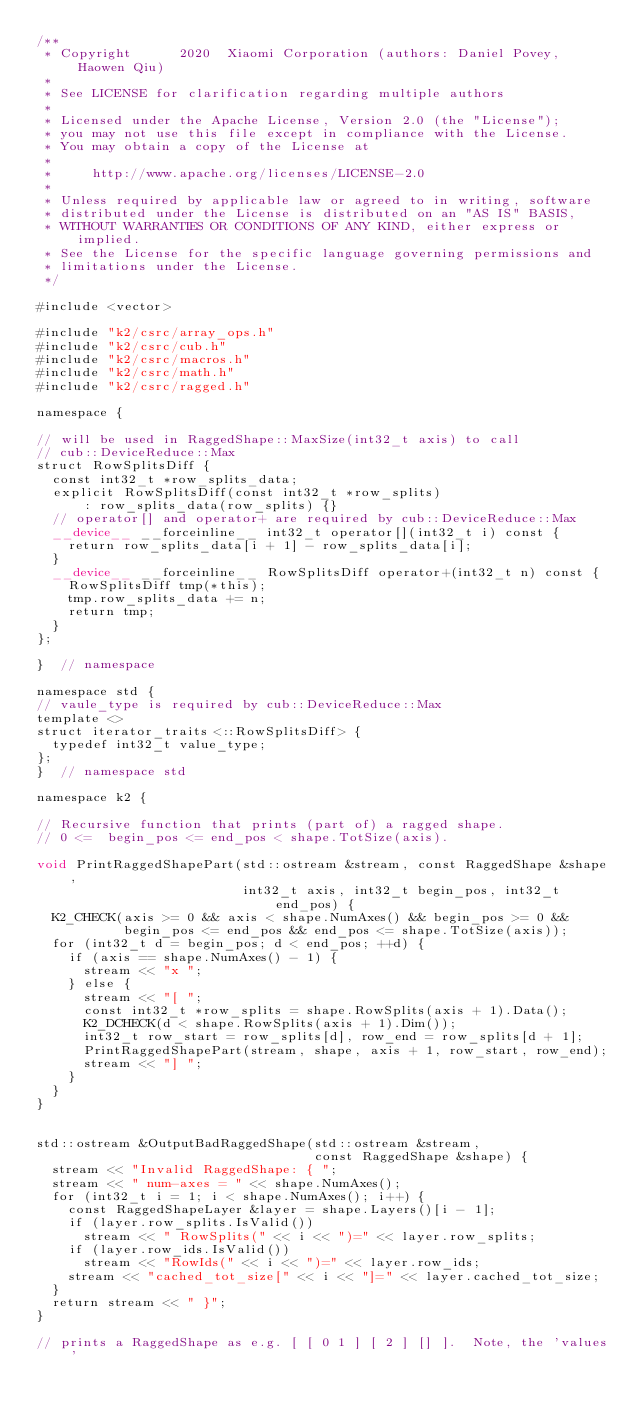Convert code to text. <code><loc_0><loc_0><loc_500><loc_500><_Cuda_>/**
 * Copyright      2020  Xiaomi Corporation (authors: Daniel Povey, Haowen Qiu)
 *
 * See LICENSE for clarification regarding multiple authors
 *
 * Licensed under the Apache License, Version 2.0 (the "License");
 * you may not use this file except in compliance with the License.
 * You may obtain a copy of the License at
 *
 *     http://www.apache.org/licenses/LICENSE-2.0
 *
 * Unless required by applicable law or agreed to in writing, software
 * distributed under the License is distributed on an "AS IS" BASIS,
 * WITHOUT WARRANTIES OR CONDITIONS OF ANY KIND, either express or implied.
 * See the License for the specific language governing permissions and
 * limitations under the License.
 */

#include <vector>

#include "k2/csrc/array_ops.h"
#include "k2/csrc/cub.h"
#include "k2/csrc/macros.h"
#include "k2/csrc/math.h"
#include "k2/csrc/ragged.h"

namespace {

// will be used in RaggedShape::MaxSize(int32_t axis) to call
// cub::DeviceReduce::Max
struct RowSplitsDiff {
  const int32_t *row_splits_data;
  explicit RowSplitsDiff(const int32_t *row_splits)
      : row_splits_data(row_splits) {}
  // operator[] and operator+ are required by cub::DeviceReduce::Max
  __device__ __forceinline__ int32_t operator[](int32_t i) const {
    return row_splits_data[i + 1] - row_splits_data[i];
  }
  __device__ __forceinline__ RowSplitsDiff operator+(int32_t n) const {
    RowSplitsDiff tmp(*this);
    tmp.row_splits_data += n;
    return tmp;
  }
};

}  // namespace

namespace std {
// vaule_type is required by cub::DeviceReduce::Max
template <>
struct iterator_traits<::RowSplitsDiff> {
  typedef int32_t value_type;
};
}  // namespace std

namespace k2 {

// Recursive function that prints (part of) a ragged shape.
// 0 <=  begin_pos <= end_pos < shape.TotSize(axis).

void PrintRaggedShapePart(std::ostream &stream, const RaggedShape &shape,
                          int32_t axis, int32_t begin_pos, int32_t end_pos) {
  K2_CHECK(axis >= 0 && axis < shape.NumAxes() && begin_pos >= 0 &&
           begin_pos <= end_pos && end_pos <= shape.TotSize(axis));
  for (int32_t d = begin_pos; d < end_pos; ++d) {
    if (axis == shape.NumAxes() - 1) {
      stream << "x ";
    } else {
      stream << "[ ";
      const int32_t *row_splits = shape.RowSplits(axis + 1).Data();
      K2_DCHECK(d < shape.RowSplits(axis + 1).Dim());
      int32_t row_start = row_splits[d], row_end = row_splits[d + 1];
      PrintRaggedShapePart(stream, shape, axis + 1, row_start, row_end);
      stream << "] ";
    }
  }
}


std::ostream &OutputBadRaggedShape(std::ostream &stream,
                                   const RaggedShape &shape) {
  stream << "Invalid RaggedShape: { ";
  stream << " num-axes = " << shape.NumAxes();
  for (int32_t i = 1; i < shape.NumAxes(); i++) {
    const RaggedShapeLayer &layer = shape.Layers()[i - 1];
    if (layer.row_splits.IsValid())
      stream << " RowSplits(" << i << ")=" << layer.row_splits;
    if (layer.row_ids.IsValid())
      stream << "RowIds(" << i << ")=" << layer.row_ids;
    stream << "cached_tot_size[" << i << "]=" << layer.cached_tot_size;
  }
  return stream << " }";
}

// prints a RaggedShape as e.g. [ [ 0 1 ] [ 2 ] [] ].  Note, the 'values'</code> 